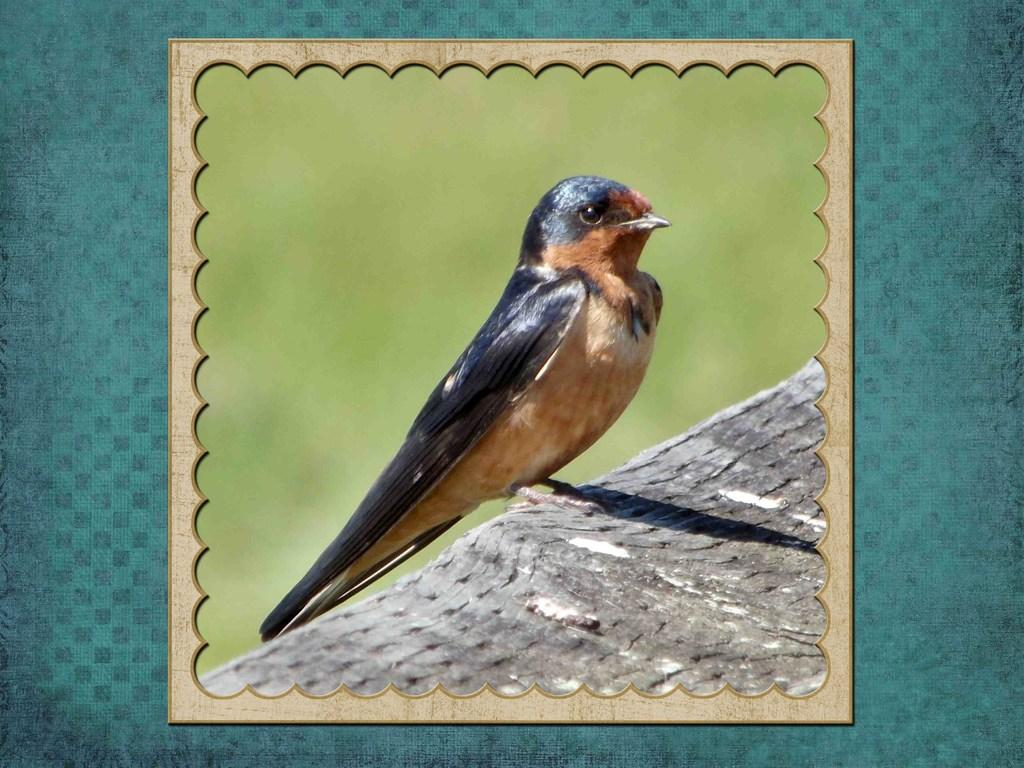What type of bird is in the image? There is a black and brown colored bird in the image. What colors can be seen in the background of the image? The background of the image includes green and blue colors. How does the bird maintain its balance on the boot in the image? There is no boot present in the image, and therefore no need for the bird to maintain its balance on one. 